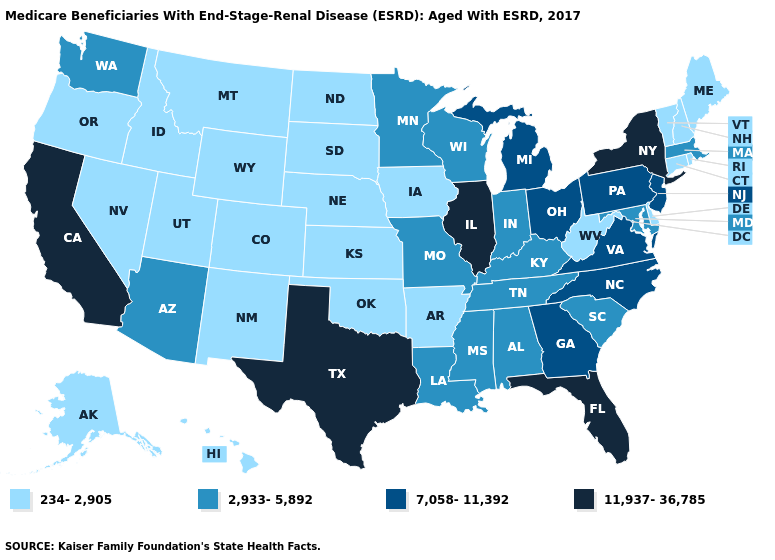What is the value of Missouri?
Concise answer only. 2,933-5,892. What is the value of Oregon?
Give a very brief answer. 234-2,905. What is the highest value in states that border Iowa?
Answer briefly. 11,937-36,785. Name the states that have a value in the range 11,937-36,785?
Write a very short answer. California, Florida, Illinois, New York, Texas. Does Indiana have the lowest value in the MidWest?
Keep it brief. No. Does the map have missing data?
Short answer required. No. What is the lowest value in the West?
Keep it brief. 234-2,905. Among the states that border Michigan , which have the highest value?
Write a very short answer. Ohio. Which states have the lowest value in the USA?
Be succinct. Alaska, Arkansas, Colorado, Connecticut, Delaware, Hawaii, Idaho, Iowa, Kansas, Maine, Montana, Nebraska, Nevada, New Hampshire, New Mexico, North Dakota, Oklahoma, Oregon, Rhode Island, South Dakota, Utah, Vermont, West Virginia, Wyoming. Name the states that have a value in the range 11,937-36,785?
Be succinct. California, Florida, Illinois, New York, Texas. What is the value of Vermont?
Quick response, please. 234-2,905. Is the legend a continuous bar?
Short answer required. No. What is the lowest value in the South?
Write a very short answer. 234-2,905. Name the states that have a value in the range 11,937-36,785?
Write a very short answer. California, Florida, Illinois, New York, Texas. 